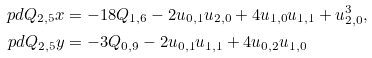<formula> <loc_0><loc_0><loc_500><loc_500>\ p d { Q _ { 2 , 5 } } { x } & = - 1 8 Q _ { 1 , 6 } - 2 u _ { 0 , 1 } u _ { 2 , 0 } + 4 u _ { 1 , 0 } u _ { 1 , 1 } + u _ { 2 , 0 } ^ { 3 } , \\ \ p d { Q _ { 2 , 5 } } { y } & = - 3 Q _ { 0 , 9 } - 2 u _ { 0 , 1 } u _ { 1 , 1 } + 4 u _ { 0 , 2 } u _ { 1 , 0 }</formula> 